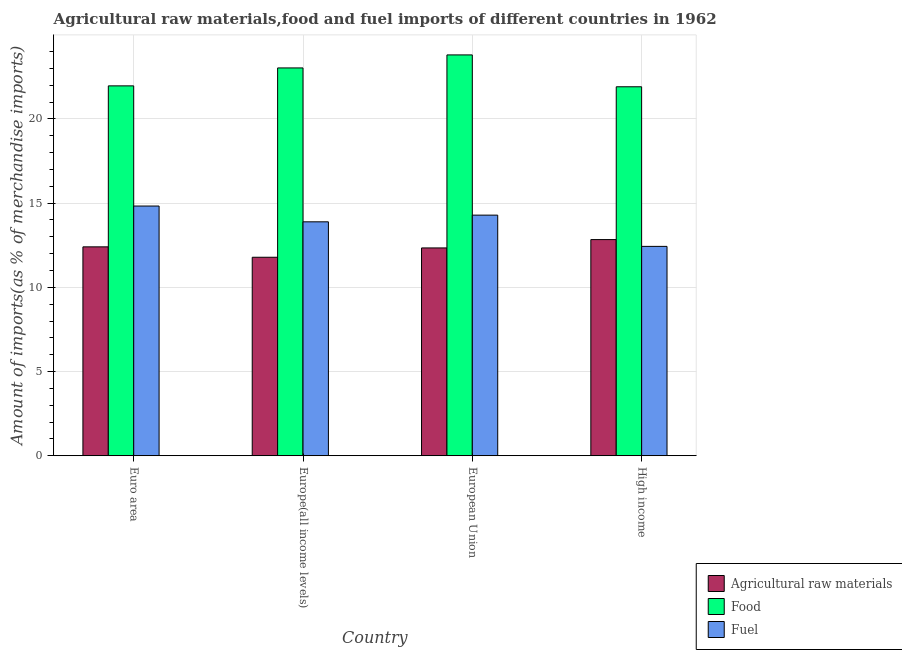How many different coloured bars are there?
Your answer should be very brief. 3. Are the number of bars on each tick of the X-axis equal?
Give a very brief answer. Yes. How many bars are there on the 3rd tick from the right?
Your answer should be very brief. 3. What is the label of the 4th group of bars from the left?
Your answer should be very brief. High income. What is the percentage of food imports in European Union?
Keep it short and to the point. 23.8. Across all countries, what is the maximum percentage of raw materials imports?
Give a very brief answer. 12.84. Across all countries, what is the minimum percentage of fuel imports?
Ensure brevity in your answer.  12.43. In which country was the percentage of food imports maximum?
Give a very brief answer. European Union. In which country was the percentage of raw materials imports minimum?
Your answer should be very brief. Europe(all income levels). What is the total percentage of fuel imports in the graph?
Your answer should be very brief. 55.44. What is the difference between the percentage of raw materials imports in European Union and that in High income?
Offer a terse response. -0.5. What is the difference between the percentage of raw materials imports in Euro area and the percentage of food imports in European Union?
Offer a terse response. -11.4. What is the average percentage of raw materials imports per country?
Ensure brevity in your answer.  12.34. What is the difference between the percentage of raw materials imports and percentage of fuel imports in Euro area?
Give a very brief answer. -2.42. What is the ratio of the percentage of raw materials imports in Europe(all income levels) to that in European Union?
Your answer should be compact. 0.96. Is the percentage of food imports in European Union less than that in High income?
Provide a short and direct response. No. Is the difference between the percentage of raw materials imports in European Union and High income greater than the difference between the percentage of food imports in European Union and High income?
Your response must be concise. No. What is the difference between the highest and the second highest percentage of fuel imports?
Offer a very short reply. 0.54. What is the difference between the highest and the lowest percentage of food imports?
Offer a very short reply. 1.89. What does the 3rd bar from the left in High income represents?
Provide a short and direct response. Fuel. What does the 1st bar from the right in Euro area represents?
Provide a short and direct response. Fuel. How many bars are there?
Give a very brief answer. 12. Are all the bars in the graph horizontal?
Make the answer very short. No. What is the difference between two consecutive major ticks on the Y-axis?
Ensure brevity in your answer.  5. What is the title of the graph?
Provide a short and direct response. Agricultural raw materials,food and fuel imports of different countries in 1962. What is the label or title of the Y-axis?
Make the answer very short. Amount of imports(as % of merchandise imports). What is the Amount of imports(as % of merchandise imports) in Agricultural raw materials in Euro area?
Provide a short and direct response. 12.41. What is the Amount of imports(as % of merchandise imports) of Food in Euro area?
Provide a succinct answer. 21.97. What is the Amount of imports(as % of merchandise imports) in Fuel in Euro area?
Give a very brief answer. 14.83. What is the Amount of imports(as % of merchandise imports) in Agricultural raw materials in Europe(all income levels)?
Your response must be concise. 11.79. What is the Amount of imports(as % of merchandise imports) in Food in Europe(all income levels)?
Provide a short and direct response. 23.03. What is the Amount of imports(as % of merchandise imports) in Fuel in Europe(all income levels)?
Your response must be concise. 13.89. What is the Amount of imports(as % of merchandise imports) in Agricultural raw materials in European Union?
Give a very brief answer. 12.34. What is the Amount of imports(as % of merchandise imports) in Food in European Union?
Your answer should be very brief. 23.8. What is the Amount of imports(as % of merchandise imports) in Fuel in European Union?
Provide a short and direct response. 14.29. What is the Amount of imports(as % of merchandise imports) of Agricultural raw materials in High income?
Provide a short and direct response. 12.84. What is the Amount of imports(as % of merchandise imports) in Food in High income?
Provide a short and direct response. 21.91. What is the Amount of imports(as % of merchandise imports) in Fuel in High income?
Your answer should be compact. 12.43. Across all countries, what is the maximum Amount of imports(as % of merchandise imports) of Agricultural raw materials?
Give a very brief answer. 12.84. Across all countries, what is the maximum Amount of imports(as % of merchandise imports) of Food?
Your response must be concise. 23.8. Across all countries, what is the maximum Amount of imports(as % of merchandise imports) in Fuel?
Your answer should be compact. 14.83. Across all countries, what is the minimum Amount of imports(as % of merchandise imports) of Agricultural raw materials?
Your response must be concise. 11.79. Across all countries, what is the minimum Amount of imports(as % of merchandise imports) in Food?
Ensure brevity in your answer.  21.91. Across all countries, what is the minimum Amount of imports(as % of merchandise imports) in Fuel?
Give a very brief answer. 12.43. What is the total Amount of imports(as % of merchandise imports) of Agricultural raw materials in the graph?
Ensure brevity in your answer.  49.37. What is the total Amount of imports(as % of merchandise imports) in Food in the graph?
Your answer should be compact. 90.71. What is the total Amount of imports(as % of merchandise imports) in Fuel in the graph?
Give a very brief answer. 55.44. What is the difference between the Amount of imports(as % of merchandise imports) of Agricultural raw materials in Euro area and that in Europe(all income levels)?
Offer a terse response. 0.62. What is the difference between the Amount of imports(as % of merchandise imports) in Food in Euro area and that in Europe(all income levels)?
Offer a very short reply. -1.07. What is the difference between the Amount of imports(as % of merchandise imports) in Fuel in Euro area and that in Europe(all income levels)?
Keep it short and to the point. 0.94. What is the difference between the Amount of imports(as % of merchandise imports) of Agricultural raw materials in Euro area and that in European Union?
Provide a short and direct response. 0.06. What is the difference between the Amount of imports(as % of merchandise imports) in Food in Euro area and that in European Union?
Your answer should be very brief. -1.84. What is the difference between the Amount of imports(as % of merchandise imports) in Fuel in Euro area and that in European Union?
Offer a terse response. 0.54. What is the difference between the Amount of imports(as % of merchandise imports) of Agricultural raw materials in Euro area and that in High income?
Ensure brevity in your answer.  -0.43. What is the difference between the Amount of imports(as % of merchandise imports) of Food in Euro area and that in High income?
Your response must be concise. 0.05. What is the difference between the Amount of imports(as % of merchandise imports) in Fuel in Euro area and that in High income?
Give a very brief answer. 2.4. What is the difference between the Amount of imports(as % of merchandise imports) in Agricultural raw materials in Europe(all income levels) and that in European Union?
Your answer should be very brief. -0.55. What is the difference between the Amount of imports(as % of merchandise imports) of Food in Europe(all income levels) and that in European Union?
Offer a very short reply. -0.77. What is the difference between the Amount of imports(as % of merchandise imports) of Fuel in Europe(all income levels) and that in European Union?
Your answer should be compact. -0.4. What is the difference between the Amount of imports(as % of merchandise imports) of Agricultural raw materials in Europe(all income levels) and that in High income?
Give a very brief answer. -1.05. What is the difference between the Amount of imports(as % of merchandise imports) in Food in Europe(all income levels) and that in High income?
Give a very brief answer. 1.12. What is the difference between the Amount of imports(as % of merchandise imports) in Fuel in Europe(all income levels) and that in High income?
Make the answer very short. 1.46. What is the difference between the Amount of imports(as % of merchandise imports) in Agricultural raw materials in European Union and that in High income?
Ensure brevity in your answer.  -0.5. What is the difference between the Amount of imports(as % of merchandise imports) in Food in European Union and that in High income?
Provide a short and direct response. 1.89. What is the difference between the Amount of imports(as % of merchandise imports) of Fuel in European Union and that in High income?
Make the answer very short. 1.86. What is the difference between the Amount of imports(as % of merchandise imports) in Agricultural raw materials in Euro area and the Amount of imports(as % of merchandise imports) in Food in Europe(all income levels)?
Ensure brevity in your answer.  -10.63. What is the difference between the Amount of imports(as % of merchandise imports) of Agricultural raw materials in Euro area and the Amount of imports(as % of merchandise imports) of Fuel in Europe(all income levels)?
Offer a very short reply. -1.49. What is the difference between the Amount of imports(as % of merchandise imports) of Food in Euro area and the Amount of imports(as % of merchandise imports) of Fuel in Europe(all income levels)?
Offer a terse response. 8.07. What is the difference between the Amount of imports(as % of merchandise imports) of Agricultural raw materials in Euro area and the Amount of imports(as % of merchandise imports) of Food in European Union?
Offer a very short reply. -11.4. What is the difference between the Amount of imports(as % of merchandise imports) in Agricultural raw materials in Euro area and the Amount of imports(as % of merchandise imports) in Fuel in European Union?
Provide a succinct answer. -1.88. What is the difference between the Amount of imports(as % of merchandise imports) in Food in Euro area and the Amount of imports(as % of merchandise imports) in Fuel in European Union?
Your response must be concise. 7.68. What is the difference between the Amount of imports(as % of merchandise imports) in Agricultural raw materials in Euro area and the Amount of imports(as % of merchandise imports) in Food in High income?
Ensure brevity in your answer.  -9.51. What is the difference between the Amount of imports(as % of merchandise imports) in Agricultural raw materials in Euro area and the Amount of imports(as % of merchandise imports) in Fuel in High income?
Your answer should be compact. -0.03. What is the difference between the Amount of imports(as % of merchandise imports) of Food in Euro area and the Amount of imports(as % of merchandise imports) of Fuel in High income?
Your answer should be very brief. 9.53. What is the difference between the Amount of imports(as % of merchandise imports) of Agricultural raw materials in Europe(all income levels) and the Amount of imports(as % of merchandise imports) of Food in European Union?
Provide a succinct answer. -12.02. What is the difference between the Amount of imports(as % of merchandise imports) in Agricultural raw materials in Europe(all income levels) and the Amount of imports(as % of merchandise imports) in Fuel in European Union?
Keep it short and to the point. -2.5. What is the difference between the Amount of imports(as % of merchandise imports) in Food in Europe(all income levels) and the Amount of imports(as % of merchandise imports) in Fuel in European Union?
Provide a short and direct response. 8.74. What is the difference between the Amount of imports(as % of merchandise imports) of Agricultural raw materials in Europe(all income levels) and the Amount of imports(as % of merchandise imports) of Food in High income?
Provide a short and direct response. -10.12. What is the difference between the Amount of imports(as % of merchandise imports) in Agricultural raw materials in Europe(all income levels) and the Amount of imports(as % of merchandise imports) in Fuel in High income?
Give a very brief answer. -0.65. What is the difference between the Amount of imports(as % of merchandise imports) in Food in Europe(all income levels) and the Amount of imports(as % of merchandise imports) in Fuel in High income?
Your answer should be compact. 10.6. What is the difference between the Amount of imports(as % of merchandise imports) in Agricultural raw materials in European Union and the Amount of imports(as % of merchandise imports) in Food in High income?
Make the answer very short. -9.57. What is the difference between the Amount of imports(as % of merchandise imports) in Agricultural raw materials in European Union and the Amount of imports(as % of merchandise imports) in Fuel in High income?
Provide a short and direct response. -0.09. What is the difference between the Amount of imports(as % of merchandise imports) in Food in European Union and the Amount of imports(as % of merchandise imports) in Fuel in High income?
Offer a terse response. 11.37. What is the average Amount of imports(as % of merchandise imports) in Agricultural raw materials per country?
Offer a very short reply. 12.34. What is the average Amount of imports(as % of merchandise imports) of Food per country?
Offer a terse response. 22.68. What is the average Amount of imports(as % of merchandise imports) of Fuel per country?
Offer a very short reply. 13.86. What is the difference between the Amount of imports(as % of merchandise imports) in Agricultural raw materials and Amount of imports(as % of merchandise imports) in Food in Euro area?
Keep it short and to the point. -9.56. What is the difference between the Amount of imports(as % of merchandise imports) in Agricultural raw materials and Amount of imports(as % of merchandise imports) in Fuel in Euro area?
Offer a very short reply. -2.42. What is the difference between the Amount of imports(as % of merchandise imports) of Food and Amount of imports(as % of merchandise imports) of Fuel in Euro area?
Offer a terse response. 7.14. What is the difference between the Amount of imports(as % of merchandise imports) of Agricultural raw materials and Amount of imports(as % of merchandise imports) of Food in Europe(all income levels)?
Make the answer very short. -11.24. What is the difference between the Amount of imports(as % of merchandise imports) of Agricultural raw materials and Amount of imports(as % of merchandise imports) of Fuel in Europe(all income levels)?
Make the answer very short. -2.1. What is the difference between the Amount of imports(as % of merchandise imports) of Food and Amount of imports(as % of merchandise imports) of Fuel in Europe(all income levels)?
Provide a short and direct response. 9.14. What is the difference between the Amount of imports(as % of merchandise imports) in Agricultural raw materials and Amount of imports(as % of merchandise imports) in Food in European Union?
Give a very brief answer. -11.46. What is the difference between the Amount of imports(as % of merchandise imports) of Agricultural raw materials and Amount of imports(as % of merchandise imports) of Fuel in European Union?
Offer a terse response. -1.95. What is the difference between the Amount of imports(as % of merchandise imports) of Food and Amount of imports(as % of merchandise imports) of Fuel in European Union?
Offer a very short reply. 9.52. What is the difference between the Amount of imports(as % of merchandise imports) in Agricultural raw materials and Amount of imports(as % of merchandise imports) in Food in High income?
Offer a very short reply. -9.08. What is the difference between the Amount of imports(as % of merchandise imports) in Agricultural raw materials and Amount of imports(as % of merchandise imports) in Fuel in High income?
Make the answer very short. 0.4. What is the difference between the Amount of imports(as % of merchandise imports) in Food and Amount of imports(as % of merchandise imports) in Fuel in High income?
Ensure brevity in your answer.  9.48. What is the ratio of the Amount of imports(as % of merchandise imports) of Agricultural raw materials in Euro area to that in Europe(all income levels)?
Keep it short and to the point. 1.05. What is the ratio of the Amount of imports(as % of merchandise imports) in Food in Euro area to that in Europe(all income levels)?
Your response must be concise. 0.95. What is the ratio of the Amount of imports(as % of merchandise imports) in Fuel in Euro area to that in Europe(all income levels)?
Provide a short and direct response. 1.07. What is the ratio of the Amount of imports(as % of merchandise imports) of Food in Euro area to that in European Union?
Offer a very short reply. 0.92. What is the ratio of the Amount of imports(as % of merchandise imports) of Fuel in Euro area to that in European Union?
Provide a short and direct response. 1.04. What is the ratio of the Amount of imports(as % of merchandise imports) in Agricultural raw materials in Euro area to that in High income?
Your answer should be very brief. 0.97. What is the ratio of the Amount of imports(as % of merchandise imports) in Food in Euro area to that in High income?
Offer a very short reply. 1. What is the ratio of the Amount of imports(as % of merchandise imports) in Fuel in Euro area to that in High income?
Give a very brief answer. 1.19. What is the ratio of the Amount of imports(as % of merchandise imports) in Agricultural raw materials in Europe(all income levels) to that in European Union?
Provide a succinct answer. 0.96. What is the ratio of the Amount of imports(as % of merchandise imports) of Food in Europe(all income levels) to that in European Union?
Your response must be concise. 0.97. What is the ratio of the Amount of imports(as % of merchandise imports) in Fuel in Europe(all income levels) to that in European Union?
Give a very brief answer. 0.97. What is the ratio of the Amount of imports(as % of merchandise imports) of Agricultural raw materials in Europe(all income levels) to that in High income?
Provide a succinct answer. 0.92. What is the ratio of the Amount of imports(as % of merchandise imports) in Food in Europe(all income levels) to that in High income?
Your answer should be very brief. 1.05. What is the ratio of the Amount of imports(as % of merchandise imports) of Fuel in Europe(all income levels) to that in High income?
Your response must be concise. 1.12. What is the ratio of the Amount of imports(as % of merchandise imports) of Agricultural raw materials in European Union to that in High income?
Your answer should be very brief. 0.96. What is the ratio of the Amount of imports(as % of merchandise imports) of Food in European Union to that in High income?
Make the answer very short. 1.09. What is the ratio of the Amount of imports(as % of merchandise imports) in Fuel in European Union to that in High income?
Your response must be concise. 1.15. What is the difference between the highest and the second highest Amount of imports(as % of merchandise imports) in Agricultural raw materials?
Provide a succinct answer. 0.43. What is the difference between the highest and the second highest Amount of imports(as % of merchandise imports) in Food?
Your answer should be compact. 0.77. What is the difference between the highest and the second highest Amount of imports(as % of merchandise imports) in Fuel?
Give a very brief answer. 0.54. What is the difference between the highest and the lowest Amount of imports(as % of merchandise imports) of Agricultural raw materials?
Your answer should be compact. 1.05. What is the difference between the highest and the lowest Amount of imports(as % of merchandise imports) of Food?
Keep it short and to the point. 1.89. What is the difference between the highest and the lowest Amount of imports(as % of merchandise imports) of Fuel?
Offer a terse response. 2.4. 